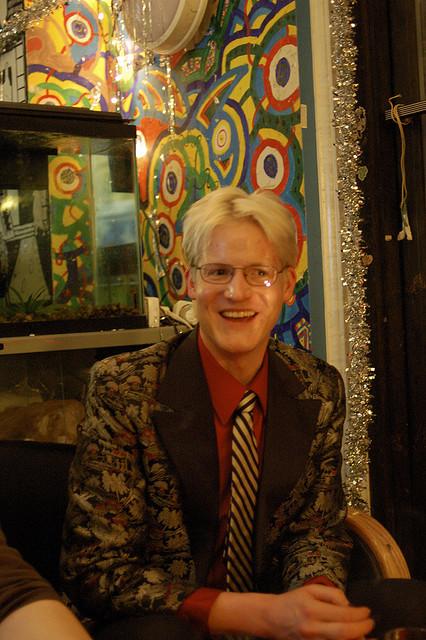What are the three types of items the shop has for sale?
Answer briefly. Unsure. What shape is present in the painting on the wall?
Give a very brief answer. Circles. Is this a military event?
Answer briefly. No. Is the man smiling?
Give a very brief answer. Yes. What color is the jackets of the people?
Be succinct. Brown. How many teeth do you see?
Concise answer only. 8. 